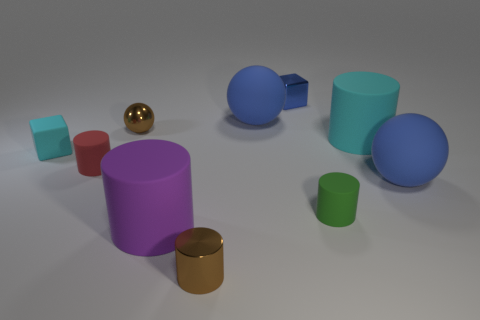There is a metal thing in front of the green rubber thing; does it have the same size as the small metallic ball?
Provide a succinct answer. Yes. What material is the big sphere that is behind the small brown object behind the big blue sphere to the right of the tiny green matte cylinder?
Your answer should be very brief. Rubber. There is a matte thing behind the big cyan rubber object; does it have the same color as the large rubber cylinder to the right of the small blue shiny cube?
Offer a terse response. No. The big ball behind the large cylinder behind the tiny red cylinder is made of what material?
Ensure brevity in your answer.  Rubber. There is another cube that is the same size as the blue metal block; what is its color?
Keep it short and to the point. Cyan. There is a large purple rubber thing; is its shape the same as the large blue object to the right of the blue metallic thing?
Offer a terse response. No. The rubber thing that is the same color as the tiny matte block is what shape?
Keep it short and to the point. Cylinder. There is a big blue thing behind the tiny cube that is in front of the tiny sphere; what number of brown shiny cylinders are to the left of it?
Provide a short and direct response. 1. There is a cyan object that is left of the large blue sphere that is to the left of the small shiny cube; what size is it?
Provide a short and direct response. Small. The brown sphere that is made of the same material as the small blue thing is what size?
Provide a short and direct response. Small. 